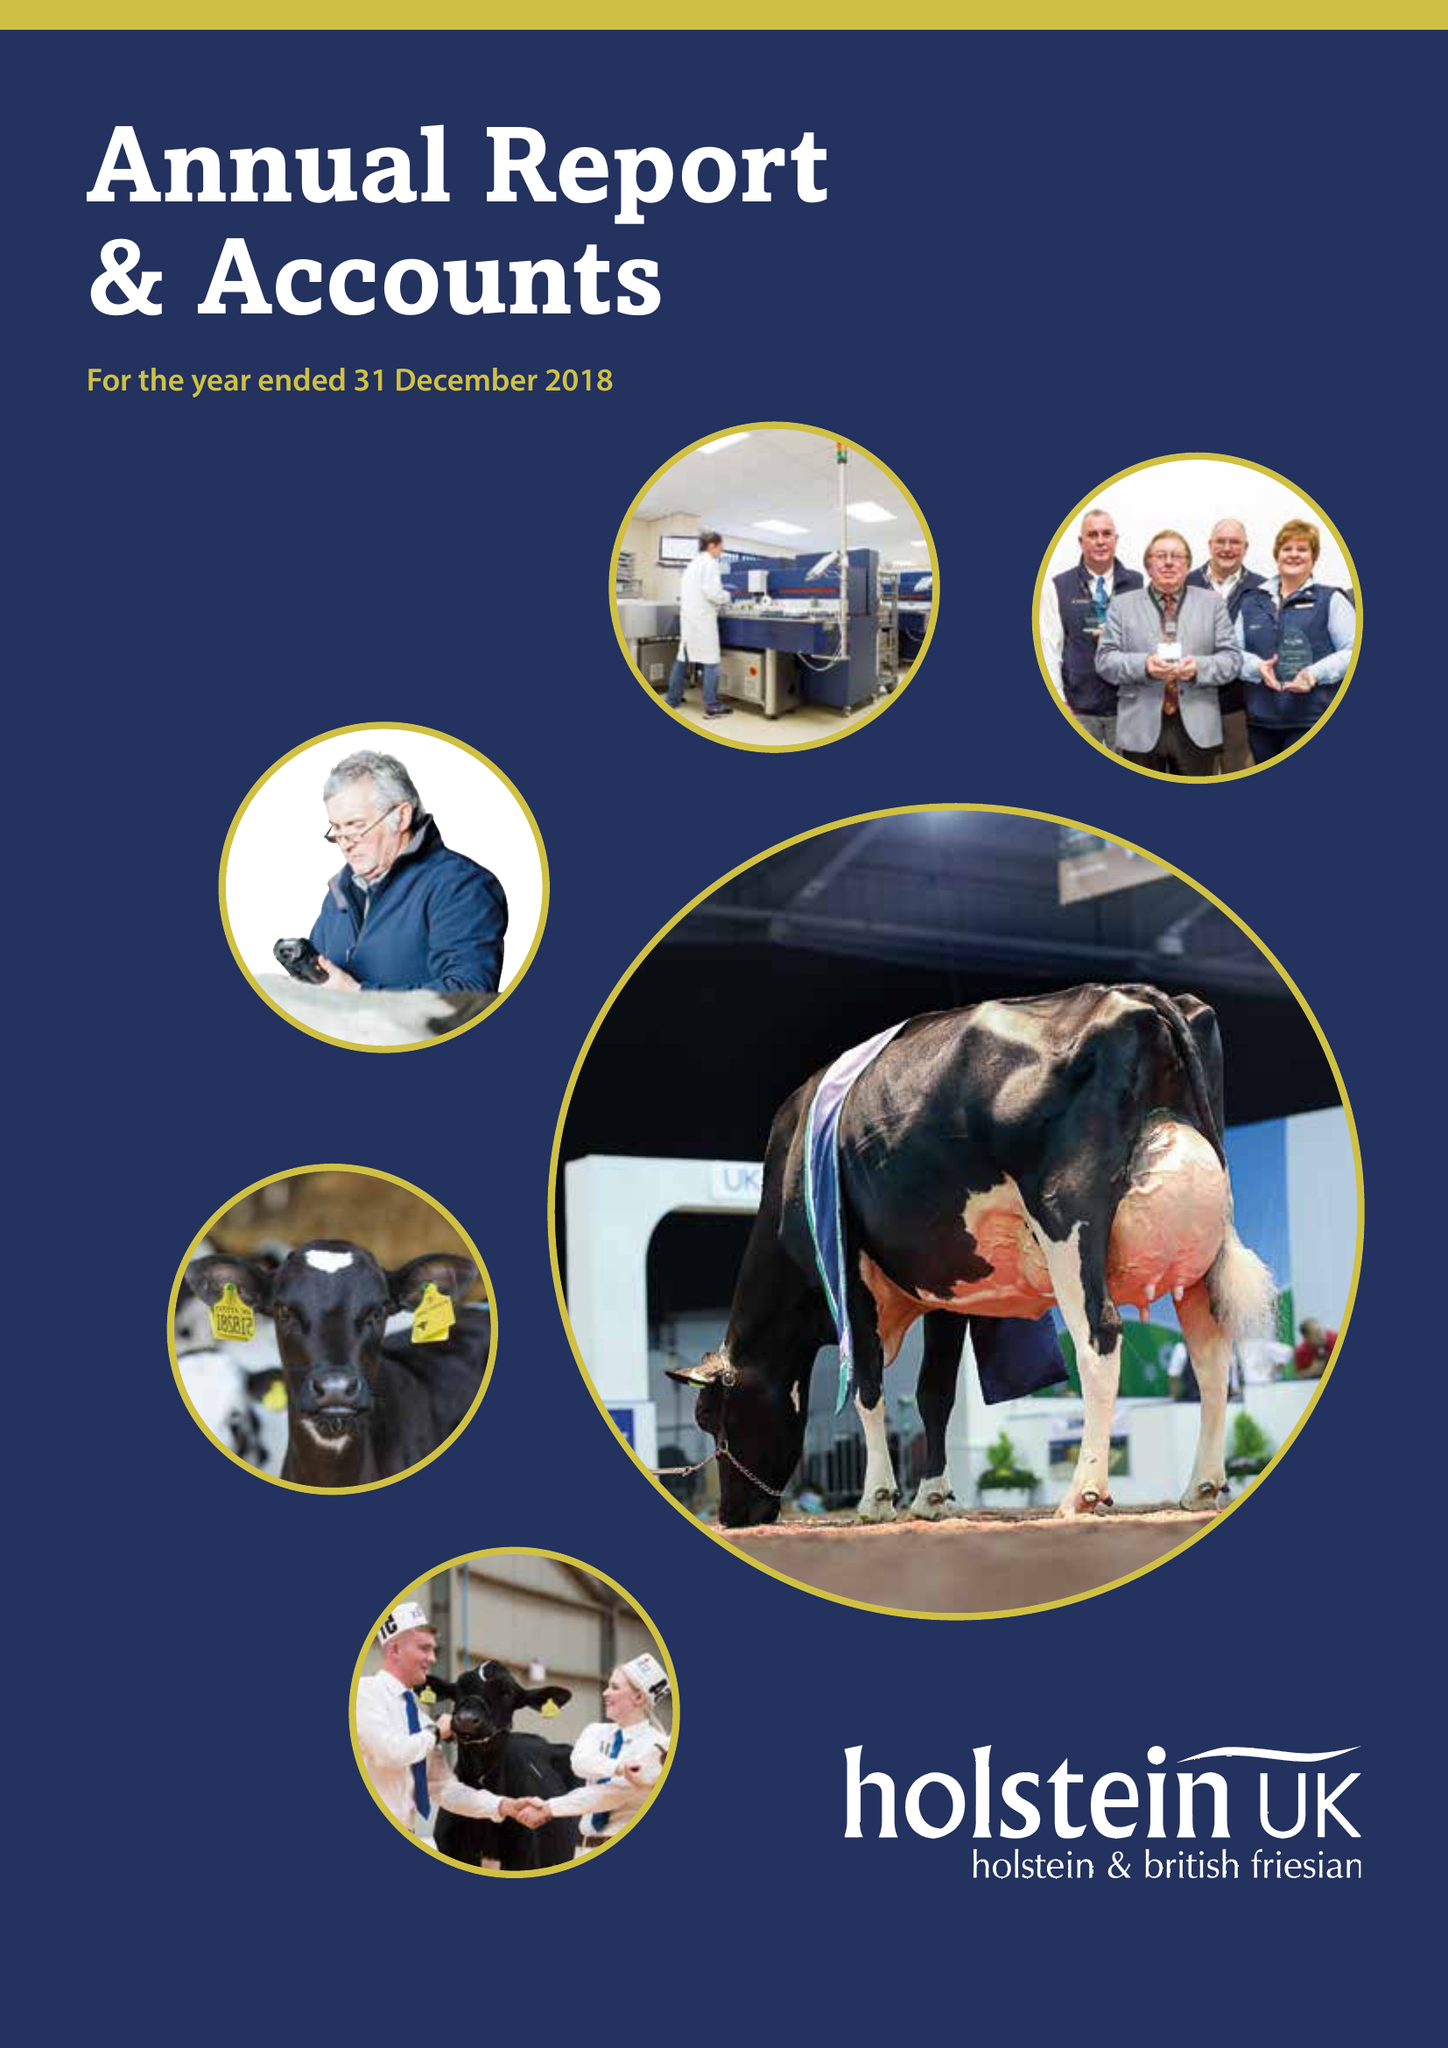What is the value for the address__street_line?
Answer the question using a single word or phrase. STAFFORD PARK 1 